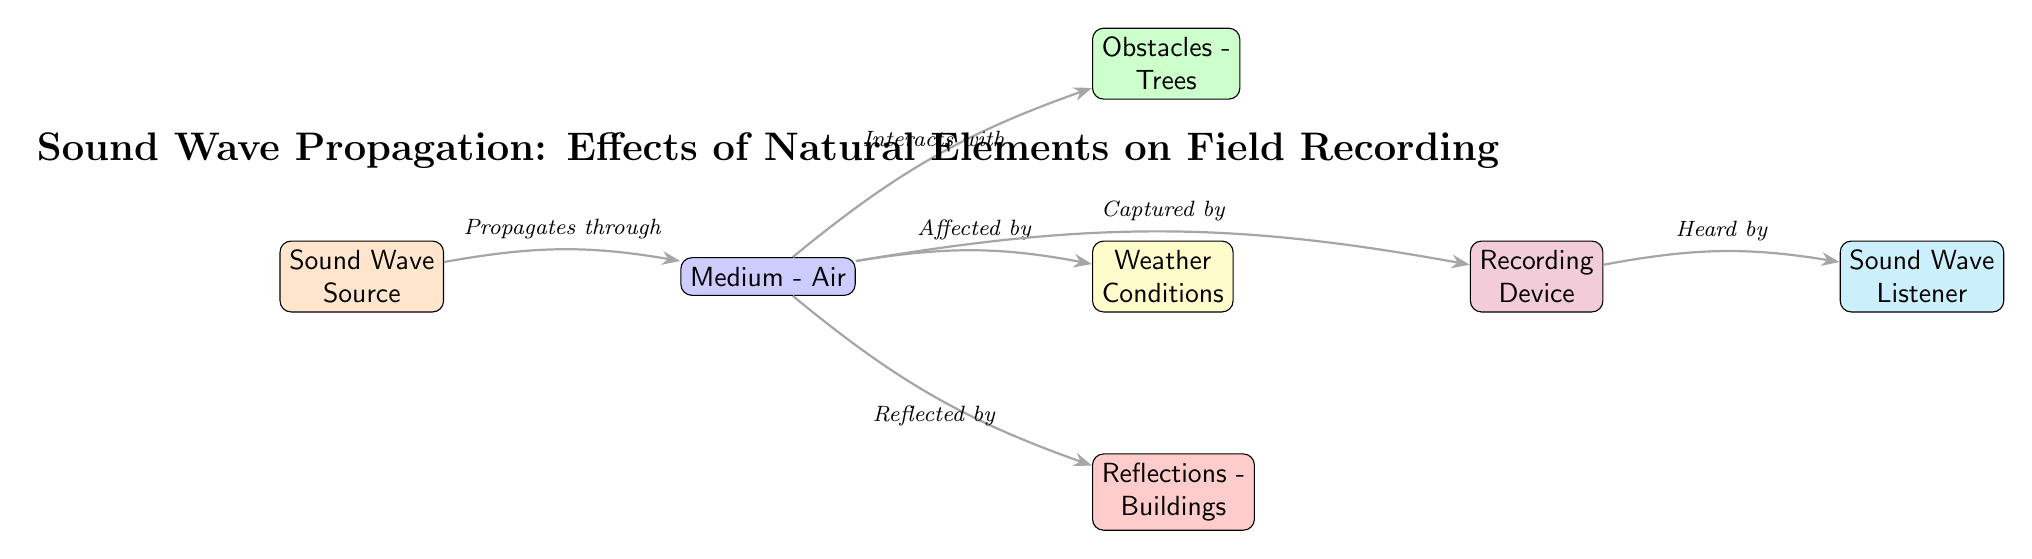What is the source of the sound wave? The diagram identifies the initial starting point for sound waves as the "Sound Wave Source," which is explicitly labeled in the diagram.
Answer: Sound Wave Source How many obstacles are shown in the diagram? The diagram displays one specific obstacle labeled "Trees" that interacts with the medium of air. There are no other obstacles indicated in the diagram.
Answer: One Which medium is depicted through which the sound wave propagates? The diagram labels "Medium - Air" as the pathway for sound wave propagation directly from the source, making it clear that air is the medium involved.
Answer: Air What happens to sound waves when they encounter buildings? The diagram shows that sound waves are "Reflected by Buildings," indicating that sound can bounce off these structures, as shown by the connected edge.
Answer: Reflected by Which element is affected by weather conditions? The edge connecting "Medium - Air" to "Weather Conditions" indicates that the air medium is influenced by weather, making it necessary for sound waves' characteristics.
Answer: Medium - Air What is captured by the recording device? According to the diagram, sound waves are explicitly stated as being "Captured by" the "Recording Device," indicating the device's role in capturing the sound after interaction with the medium.
Answer: Sound Waves In what order do sound waves move from the source to the listener? The flow in the diagram starts from the "Sound Wave Source," moves to "Medium - Air," interacts with "Obstacles - Trees" and other influences, is captured by the "Recording Device," and finally heard by the "Sound Wave Listener." This sequence illustrates the propagation process.
Answer: Sound Wave Source → Medium - Air → Obstacles - Trees → Recording Device → Sound Wave Listener What type of conditions does weather represent in the context of sound wave propagation? The diagram classifies "Weather Conditions" as factors that "Affect" the medium through which sound propagates, highlighting the impact of environmental conditions on sound travel.
Answer: Affect What is the relationship between the recording device and the listener? The diagram indicates that sound waves are "Heard by" the listener after being captured by the recording device, establishing a direct relationship between these two elements.
Answer: Heard by 